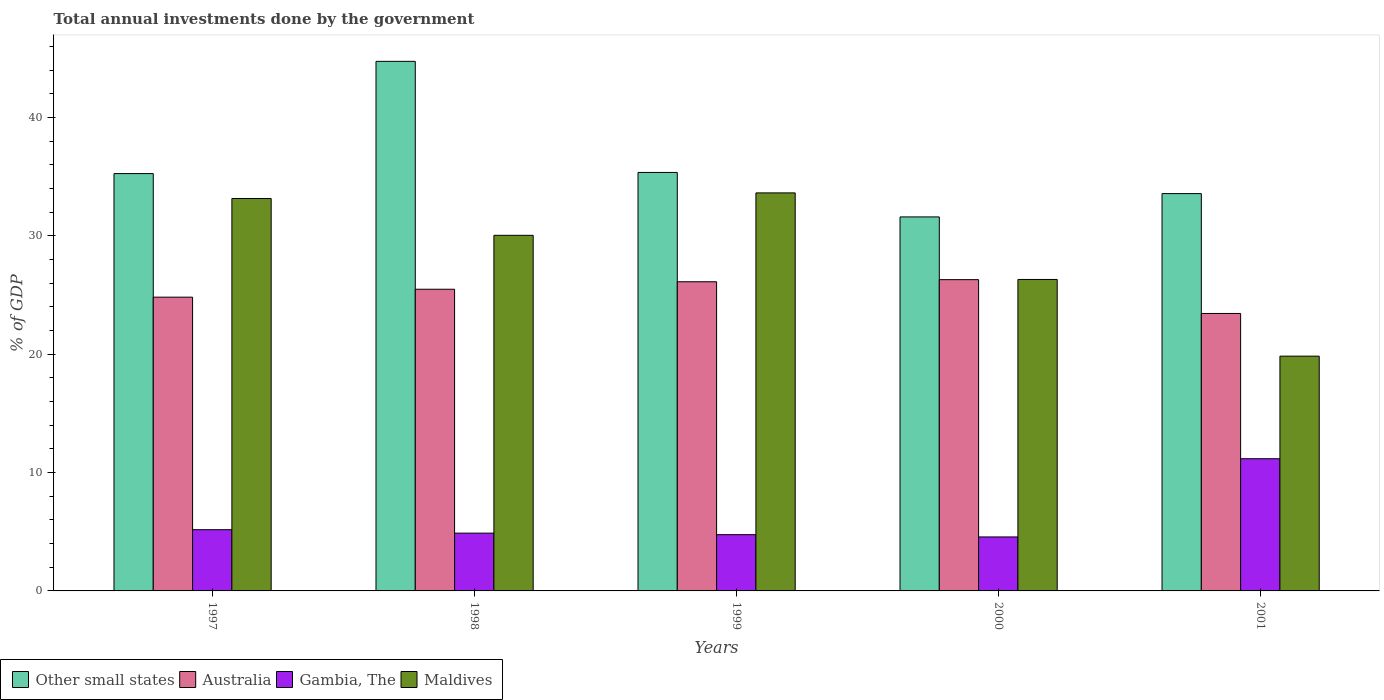How many different coloured bars are there?
Your answer should be compact. 4. Are the number of bars per tick equal to the number of legend labels?
Provide a succinct answer. Yes. What is the total annual investments done by the government in Other small states in 1997?
Make the answer very short. 35.27. Across all years, what is the maximum total annual investments done by the government in Maldives?
Give a very brief answer. 33.64. Across all years, what is the minimum total annual investments done by the government in Other small states?
Offer a very short reply. 31.61. What is the total total annual investments done by the government in Maldives in the graph?
Offer a terse response. 143.03. What is the difference between the total annual investments done by the government in Maldives in 1997 and that in 1999?
Offer a terse response. -0.47. What is the difference between the total annual investments done by the government in Maldives in 2000 and the total annual investments done by the government in Australia in 1997?
Offer a terse response. 1.5. What is the average total annual investments done by the government in Other small states per year?
Give a very brief answer. 36.12. In the year 1999, what is the difference between the total annual investments done by the government in Gambia, The and total annual investments done by the government in Other small states?
Offer a terse response. -30.61. In how many years, is the total annual investments done by the government in Maldives greater than 14 %?
Your answer should be compact. 5. What is the ratio of the total annual investments done by the government in Other small states in 1998 to that in 2001?
Provide a succinct answer. 1.33. Is the total annual investments done by the government in Australia in 1999 less than that in 2001?
Give a very brief answer. No. Is the difference between the total annual investments done by the government in Gambia, The in 1997 and 2001 greater than the difference between the total annual investments done by the government in Other small states in 1997 and 2001?
Your answer should be compact. No. What is the difference between the highest and the second highest total annual investments done by the government in Other small states?
Provide a succinct answer. 9.39. What is the difference between the highest and the lowest total annual investments done by the government in Other small states?
Keep it short and to the point. 13.15. In how many years, is the total annual investments done by the government in Gambia, The greater than the average total annual investments done by the government in Gambia, The taken over all years?
Offer a terse response. 1. What does the 1st bar from the left in 1998 represents?
Your answer should be compact. Other small states. Is it the case that in every year, the sum of the total annual investments done by the government in Gambia, The and total annual investments done by the government in Maldives is greater than the total annual investments done by the government in Australia?
Your answer should be compact. Yes. Are all the bars in the graph horizontal?
Make the answer very short. No. What is the difference between two consecutive major ticks on the Y-axis?
Provide a succinct answer. 10. Are the values on the major ticks of Y-axis written in scientific E-notation?
Your answer should be very brief. No. Does the graph contain any zero values?
Ensure brevity in your answer.  No. Does the graph contain grids?
Your response must be concise. No. How many legend labels are there?
Keep it short and to the point. 4. What is the title of the graph?
Keep it short and to the point. Total annual investments done by the government. Does "Senegal" appear as one of the legend labels in the graph?
Provide a succinct answer. No. What is the label or title of the Y-axis?
Offer a very short reply. % of GDP. What is the % of GDP of Other small states in 1997?
Provide a succinct answer. 35.27. What is the % of GDP in Australia in 1997?
Your answer should be compact. 24.83. What is the % of GDP of Gambia, The in 1997?
Keep it short and to the point. 5.18. What is the % of GDP in Maldives in 1997?
Provide a succinct answer. 33.17. What is the % of GDP of Other small states in 1998?
Give a very brief answer. 44.76. What is the % of GDP in Australia in 1998?
Provide a short and direct response. 25.5. What is the % of GDP in Gambia, The in 1998?
Make the answer very short. 4.88. What is the % of GDP of Maldives in 1998?
Give a very brief answer. 30.05. What is the % of GDP in Other small states in 1999?
Offer a very short reply. 35.37. What is the % of GDP of Australia in 1999?
Make the answer very short. 26.13. What is the % of GDP in Gambia, The in 1999?
Offer a terse response. 4.76. What is the % of GDP of Maldives in 1999?
Your answer should be compact. 33.64. What is the % of GDP in Other small states in 2000?
Your answer should be very brief. 31.61. What is the % of GDP in Australia in 2000?
Provide a short and direct response. 26.31. What is the % of GDP in Gambia, The in 2000?
Make the answer very short. 4.56. What is the % of GDP in Maldives in 2000?
Your answer should be compact. 26.32. What is the % of GDP of Other small states in 2001?
Your response must be concise. 33.58. What is the % of GDP in Australia in 2001?
Your response must be concise. 23.45. What is the % of GDP of Gambia, The in 2001?
Make the answer very short. 11.17. What is the % of GDP of Maldives in 2001?
Your answer should be compact. 19.84. Across all years, what is the maximum % of GDP of Other small states?
Your answer should be very brief. 44.76. Across all years, what is the maximum % of GDP of Australia?
Offer a terse response. 26.31. Across all years, what is the maximum % of GDP in Gambia, The?
Provide a succinct answer. 11.17. Across all years, what is the maximum % of GDP in Maldives?
Keep it short and to the point. 33.64. Across all years, what is the minimum % of GDP in Other small states?
Offer a terse response. 31.61. Across all years, what is the minimum % of GDP of Australia?
Offer a terse response. 23.45. Across all years, what is the minimum % of GDP in Gambia, The?
Provide a short and direct response. 4.56. Across all years, what is the minimum % of GDP in Maldives?
Give a very brief answer. 19.84. What is the total % of GDP of Other small states in the graph?
Keep it short and to the point. 180.59. What is the total % of GDP in Australia in the graph?
Provide a short and direct response. 126.21. What is the total % of GDP in Gambia, The in the graph?
Make the answer very short. 30.55. What is the total % of GDP in Maldives in the graph?
Provide a short and direct response. 143.03. What is the difference between the % of GDP of Other small states in 1997 and that in 1998?
Provide a short and direct response. -9.49. What is the difference between the % of GDP in Australia in 1997 and that in 1998?
Offer a very short reply. -0.67. What is the difference between the % of GDP of Gambia, The in 1997 and that in 1998?
Keep it short and to the point. 0.29. What is the difference between the % of GDP in Maldives in 1997 and that in 1998?
Ensure brevity in your answer.  3.11. What is the difference between the % of GDP of Other small states in 1997 and that in 1999?
Provide a succinct answer. -0.1. What is the difference between the % of GDP in Australia in 1997 and that in 1999?
Provide a succinct answer. -1.3. What is the difference between the % of GDP in Gambia, The in 1997 and that in 1999?
Ensure brevity in your answer.  0.42. What is the difference between the % of GDP in Maldives in 1997 and that in 1999?
Your answer should be very brief. -0.47. What is the difference between the % of GDP in Other small states in 1997 and that in 2000?
Keep it short and to the point. 3.66. What is the difference between the % of GDP in Australia in 1997 and that in 2000?
Make the answer very short. -1.48. What is the difference between the % of GDP in Gambia, The in 1997 and that in 2000?
Keep it short and to the point. 0.61. What is the difference between the % of GDP of Maldives in 1997 and that in 2000?
Your response must be concise. 6.84. What is the difference between the % of GDP in Other small states in 1997 and that in 2001?
Provide a succinct answer. 1.69. What is the difference between the % of GDP of Australia in 1997 and that in 2001?
Provide a short and direct response. 1.38. What is the difference between the % of GDP in Gambia, The in 1997 and that in 2001?
Keep it short and to the point. -6. What is the difference between the % of GDP in Maldives in 1997 and that in 2001?
Keep it short and to the point. 13.32. What is the difference between the % of GDP of Other small states in 1998 and that in 1999?
Your answer should be very brief. 9.39. What is the difference between the % of GDP of Australia in 1998 and that in 1999?
Provide a short and direct response. -0.63. What is the difference between the % of GDP in Gambia, The in 1998 and that in 1999?
Make the answer very short. 0.13. What is the difference between the % of GDP of Maldives in 1998 and that in 1999?
Your answer should be very brief. -3.59. What is the difference between the % of GDP of Other small states in 1998 and that in 2000?
Make the answer very short. 13.15. What is the difference between the % of GDP in Australia in 1998 and that in 2000?
Your answer should be very brief. -0.81. What is the difference between the % of GDP in Gambia, The in 1998 and that in 2000?
Make the answer very short. 0.32. What is the difference between the % of GDP of Maldives in 1998 and that in 2000?
Offer a terse response. 3.73. What is the difference between the % of GDP of Other small states in 1998 and that in 2001?
Make the answer very short. 11.18. What is the difference between the % of GDP in Australia in 1998 and that in 2001?
Your answer should be compact. 2.05. What is the difference between the % of GDP in Gambia, The in 1998 and that in 2001?
Provide a succinct answer. -6.29. What is the difference between the % of GDP of Maldives in 1998 and that in 2001?
Your answer should be compact. 10.21. What is the difference between the % of GDP in Other small states in 1999 and that in 2000?
Offer a terse response. 3.76. What is the difference between the % of GDP of Australia in 1999 and that in 2000?
Provide a short and direct response. -0.18. What is the difference between the % of GDP of Gambia, The in 1999 and that in 2000?
Offer a terse response. 0.19. What is the difference between the % of GDP in Maldives in 1999 and that in 2000?
Your answer should be compact. 7.32. What is the difference between the % of GDP of Other small states in 1999 and that in 2001?
Offer a terse response. 1.79. What is the difference between the % of GDP in Australia in 1999 and that in 2001?
Offer a terse response. 2.68. What is the difference between the % of GDP of Gambia, The in 1999 and that in 2001?
Provide a succinct answer. -6.42. What is the difference between the % of GDP of Maldives in 1999 and that in 2001?
Provide a succinct answer. 13.8. What is the difference between the % of GDP in Other small states in 2000 and that in 2001?
Offer a terse response. -1.97. What is the difference between the % of GDP of Australia in 2000 and that in 2001?
Keep it short and to the point. 2.86. What is the difference between the % of GDP of Gambia, The in 2000 and that in 2001?
Offer a very short reply. -6.61. What is the difference between the % of GDP in Maldives in 2000 and that in 2001?
Keep it short and to the point. 6.48. What is the difference between the % of GDP of Other small states in 1997 and the % of GDP of Australia in 1998?
Provide a succinct answer. 9.78. What is the difference between the % of GDP in Other small states in 1997 and the % of GDP in Gambia, The in 1998?
Your response must be concise. 30.39. What is the difference between the % of GDP in Other small states in 1997 and the % of GDP in Maldives in 1998?
Provide a succinct answer. 5.22. What is the difference between the % of GDP of Australia in 1997 and the % of GDP of Gambia, The in 1998?
Give a very brief answer. 19.94. What is the difference between the % of GDP of Australia in 1997 and the % of GDP of Maldives in 1998?
Give a very brief answer. -5.23. What is the difference between the % of GDP of Gambia, The in 1997 and the % of GDP of Maldives in 1998?
Your answer should be compact. -24.88. What is the difference between the % of GDP in Other small states in 1997 and the % of GDP in Australia in 1999?
Your answer should be compact. 9.14. What is the difference between the % of GDP of Other small states in 1997 and the % of GDP of Gambia, The in 1999?
Give a very brief answer. 30.52. What is the difference between the % of GDP in Other small states in 1997 and the % of GDP in Maldives in 1999?
Your response must be concise. 1.63. What is the difference between the % of GDP in Australia in 1997 and the % of GDP in Gambia, The in 1999?
Provide a short and direct response. 20.07. What is the difference between the % of GDP in Australia in 1997 and the % of GDP in Maldives in 1999?
Your answer should be very brief. -8.81. What is the difference between the % of GDP of Gambia, The in 1997 and the % of GDP of Maldives in 1999?
Your answer should be very brief. -28.46. What is the difference between the % of GDP of Other small states in 1997 and the % of GDP of Australia in 2000?
Keep it short and to the point. 8.96. What is the difference between the % of GDP of Other small states in 1997 and the % of GDP of Gambia, The in 2000?
Offer a very short reply. 30.71. What is the difference between the % of GDP in Other small states in 1997 and the % of GDP in Maldives in 2000?
Give a very brief answer. 8.95. What is the difference between the % of GDP of Australia in 1997 and the % of GDP of Gambia, The in 2000?
Your answer should be very brief. 20.27. What is the difference between the % of GDP in Australia in 1997 and the % of GDP in Maldives in 2000?
Offer a terse response. -1.5. What is the difference between the % of GDP of Gambia, The in 1997 and the % of GDP of Maldives in 2000?
Your answer should be very brief. -21.15. What is the difference between the % of GDP of Other small states in 1997 and the % of GDP of Australia in 2001?
Your response must be concise. 11.82. What is the difference between the % of GDP of Other small states in 1997 and the % of GDP of Gambia, The in 2001?
Offer a terse response. 24.1. What is the difference between the % of GDP of Other small states in 1997 and the % of GDP of Maldives in 2001?
Make the answer very short. 15.43. What is the difference between the % of GDP in Australia in 1997 and the % of GDP in Gambia, The in 2001?
Offer a very short reply. 13.65. What is the difference between the % of GDP of Australia in 1997 and the % of GDP of Maldives in 2001?
Provide a short and direct response. 4.98. What is the difference between the % of GDP of Gambia, The in 1997 and the % of GDP of Maldives in 2001?
Offer a terse response. -14.67. What is the difference between the % of GDP of Other small states in 1998 and the % of GDP of Australia in 1999?
Ensure brevity in your answer.  18.63. What is the difference between the % of GDP in Other small states in 1998 and the % of GDP in Gambia, The in 1999?
Your response must be concise. 40. What is the difference between the % of GDP of Other small states in 1998 and the % of GDP of Maldives in 1999?
Ensure brevity in your answer.  11.12. What is the difference between the % of GDP in Australia in 1998 and the % of GDP in Gambia, The in 1999?
Provide a succinct answer. 20.74. What is the difference between the % of GDP in Australia in 1998 and the % of GDP in Maldives in 1999?
Your response must be concise. -8.14. What is the difference between the % of GDP of Gambia, The in 1998 and the % of GDP of Maldives in 1999?
Provide a succinct answer. -28.76. What is the difference between the % of GDP of Other small states in 1998 and the % of GDP of Australia in 2000?
Keep it short and to the point. 18.45. What is the difference between the % of GDP of Other small states in 1998 and the % of GDP of Gambia, The in 2000?
Keep it short and to the point. 40.19. What is the difference between the % of GDP in Other small states in 1998 and the % of GDP in Maldives in 2000?
Provide a short and direct response. 18.43. What is the difference between the % of GDP in Australia in 1998 and the % of GDP in Gambia, The in 2000?
Provide a succinct answer. 20.93. What is the difference between the % of GDP in Australia in 1998 and the % of GDP in Maldives in 2000?
Make the answer very short. -0.83. What is the difference between the % of GDP of Gambia, The in 1998 and the % of GDP of Maldives in 2000?
Offer a very short reply. -21.44. What is the difference between the % of GDP in Other small states in 1998 and the % of GDP in Australia in 2001?
Provide a succinct answer. 21.31. What is the difference between the % of GDP of Other small states in 1998 and the % of GDP of Gambia, The in 2001?
Ensure brevity in your answer.  33.58. What is the difference between the % of GDP in Other small states in 1998 and the % of GDP in Maldives in 2001?
Offer a terse response. 24.91. What is the difference between the % of GDP in Australia in 1998 and the % of GDP in Gambia, The in 2001?
Keep it short and to the point. 14.32. What is the difference between the % of GDP of Australia in 1998 and the % of GDP of Maldives in 2001?
Give a very brief answer. 5.65. What is the difference between the % of GDP of Gambia, The in 1998 and the % of GDP of Maldives in 2001?
Your answer should be very brief. -14.96. What is the difference between the % of GDP of Other small states in 1999 and the % of GDP of Australia in 2000?
Your response must be concise. 9.06. What is the difference between the % of GDP in Other small states in 1999 and the % of GDP in Gambia, The in 2000?
Ensure brevity in your answer.  30.81. What is the difference between the % of GDP of Other small states in 1999 and the % of GDP of Maldives in 2000?
Offer a terse response. 9.05. What is the difference between the % of GDP in Australia in 1999 and the % of GDP in Gambia, The in 2000?
Your response must be concise. 21.57. What is the difference between the % of GDP in Australia in 1999 and the % of GDP in Maldives in 2000?
Ensure brevity in your answer.  -0.19. What is the difference between the % of GDP of Gambia, The in 1999 and the % of GDP of Maldives in 2000?
Offer a very short reply. -21.57. What is the difference between the % of GDP in Other small states in 1999 and the % of GDP in Australia in 2001?
Keep it short and to the point. 11.92. What is the difference between the % of GDP of Other small states in 1999 and the % of GDP of Gambia, The in 2001?
Give a very brief answer. 24.2. What is the difference between the % of GDP of Other small states in 1999 and the % of GDP of Maldives in 2001?
Provide a succinct answer. 15.53. What is the difference between the % of GDP of Australia in 1999 and the % of GDP of Gambia, The in 2001?
Your answer should be compact. 14.96. What is the difference between the % of GDP in Australia in 1999 and the % of GDP in Maldives in 2001?
Your answer should be very brief. 6.29. What is the difference between the % of GDP in Gambia, The in 1999 and the % of GDP in Maldives in 2001?
Keep it short and to the point. -15.09. What is the difference between the % of GDP of Other small states in 2000 and the % of GDP of Australia in 2001?
Your response must be concise. 8.16. What is the difference between the % of GDP of Other small states in 2000 and the % of GDP of Gambia, The in 2001?
Your answer should be compact. 20.44. What is the difference between the % of GDP in Other small states in 2000 and the % of GDP in Maldives in 2001?
Your response must be concise. 11.77. What is the difference between the % of GDP in Australia in 2000 and the % of GDP in Gambia, The in 2001?
Your answer should be very brief. 15.13. What is the difference between the % of GDP in Australia in 2000 and the % of GDP in Maldives in 2001?
Provide a succinct answer. 6.46. What is the difference between the % of GDP in Gambia, The in 2000 and the % of GDP in Maldives in 2001?
Give a very brief answer. -15.28. What is the average % of GDP in Other small states per year?
Your answer should be compact. 36.12. What is the average % of GDP in Australia per year?
Offer a very short reply. 25.24. What is the average % of GDP in Gambia, The per year?
Offer a very short reply. 6.11. What is the average % of GDP of Maldives per year?
Offer a very short reply. 28.61. In the year 1997, what is the difference between the % of GDP of Other small states and % of GDP of Australia?
Your answer should be very brief. 10.44. In the year 1997, what is the difference between the % of GDP in Other small states and % of GDP in Gambia, The?
Make the answer very short. 30.1. In the year 1997, what is the difference between the % of GDP of Other small states and % of GDP of Maldives?
Provide a succinct answer. 2.11. In the year 1997, what is the difference between the % of GDP of Australia and % of GDP of Gambia, The?
Give a very brief answer. 19.65. In the year 1997, what is the difference between the % of GDP of Australia and % of GDP of Maldives?
Offer a very short reply. -8.34. In the year 1997, what is the difference between the % of GDP in Gambia, The and % of GDP in Maldives?
Keep it short and to the point. -27.99. In the year 1998, what is the difference between the % of GDP in Other small states and % of GDP in Australia?
Your response must be concise. 19.26. In the year 1998, what is the difference between the % of GDP in Other small states and % of GDP in Gambia, The?
Give a very brief answer. 39.87. In the year 1998, what is the difference between the % of GDP of Other small states and % of GDP of Maldives?
Keep it short and to the point. 14.7. In the year 1998, what is the difference between the % of GDP in Australia and % of GDP in Gambia, The?
Your response must be concise. 20.61. In the year 1998, what is the difference between the % of GDP of Australia and % of GDP of Maldives?
Give a very brief answer. -4.56. In the year 1998, what is the difference between the % of GDP in Gambia, The and % of GDP in Maldives?
Give a very brief answer. -25.17. In the year 1999, what is the difference between the % of GDP in Other small states and % of GDP in Australia?
Make the answer very short. 9.24. In the year 1999, what is the difference between the % of GDP in Other small states and % of GDP in Gambia, The?
Ensure brevity in your answer.  30.61. In the year 1999, what is the difference between the % of GDP in Other small states and % of GDP in Maldives?
Provide a short and direct response. 1.73. In the year 1999, what is the difference between the % of GDP in Australia and % of GDP in Gambia, The?
Your answer should be compact. 21.37. In the year 1999, what is the difference between the % of GDP of Australia and % of GDP of Maldives?
Your answer should be compact. -7.51. In the year 1999, what is the difference between the % of GDP of Gambia, The and % of GDP of Maldives?
Your response must be concise. -28.88. In the year 2000, what is the difference between the % of GDP of Other small states and % of GDP of Australia?
Your answer should be very brief. 5.3. In the year 2000, what is the difference between the % of GDP of Other small states and % of GDP of Gambia, The?
Make the answer very short. 27.05. In the year 2000, what is the difference between the % of GDP in Other small states and % of GDP in Maldives?
Keep it short and to the point. 5.29. In the year 2000, what is the difference between the % of GDP in Australia and % of GDP in Gambia, The?
Offer a terse response. 21.75. In the year 2000, what is the difference between the % of GDP of Australia and % of GDP of Maldives?
Keep it short and to the point. -0.02. In the year 2000, what is the difference between the % of GDP of Gambia, The and % of GDP of Maldives?
Make the answer very short. -21.76. In the year 2001, what is the difference between the % of GDP of Other small states and % of GDP of Australia?
Make the answer very short. 10.13. In the year 2001, what is the difference between the % of GDP of Other small states and % of GDP of Gambia, The?
Offer a very short reply. 22.41. In the year 2001, what is the difference between the % of GDP in Other small states and % of GDP in Maldives?
Your answer should be very brief. 13.74. In the year 2001, what is the difference between the % of GDP in Australia and % of GDP in Gambia, The?
Provide a succinct answer. 12.28. In the year 2001, what is the difference between the % of GDP of Australia and % of GDP of Maldives?
Provide a short and direct response. 3.61. In the year 2001, what is the difference between the % of GDP of Gambia, The and % of GDP of Maldives?
Provide a succinct answer. -8.67. What is the ratio of the % of GDP of Other small states in 1997 to that in 1998?
Keep it short and to the point. 0.79. What is the ratio of the % of GDP of Australia in 1997 to that in 1998?
Your response must be concise. 0.97. What is the ratio of the % of GDP of Gambia, The in 1997 to that in 1998?
Provide a succinct answer. 1.06. What is the ratio of the % of GDP in Maldives in 1997 to that in 1998?
Ensure brevity in your answer.  1.1. What is the ratio of the % of GDP in Australia in 1997 to that in 1999?
Provide a short and direct response. 0.95. What is the ratio of the % of GDP of Gambia, The in 1997 to that in 1999?
Your answer should be very brief. 1.09. What is the ratio of the % of GDP of Maldives in 1997 to that in 1999?
Keep it short and to the point. 0.99. What is the ratio of the % of GDP in Other small states in 1997 to that in 2000?
Offer a very short reply. 1.12. What is the ratio of the % of GDP of Australia in 1997 to that in 2000?
Make the answer very short. 0.94. What is the ratio of the % of GDP in Gambia, The in 1997 to that in 2000?
Provide a short and direct response. 1.13. What is the ratio of the % of GDP in Maldives in 1997 to that in 2000?
Your answer should be compact. 1.26. What is the ratio of the % of GDP in Other small states in 1997 to that in 2001?
Offer a very short reply. 1.05. What is the ratio of the % of GDP in Australia in 1997 to that in 2001?
Give a very brief answer. 1.06. What is the ratio of the % of GDP of Gambia, The in 1997 to that in 2001?
Keep it short and to the point. 0.46. What is the ratio of the % of GDP of Maldives in 1997 to that in 2001?
Your answer should be compact. 1.67. What is the ratio of the % of GDP in Other small states in 1998 to that in 1999?
Your answer should be very brief. 1.27. What is the ratio of the % of GDP of Australia in 1998 to that in 1999?
Ensure brevity in your answer.  0.98. What is the ratio of the % of GDP in Gambia, The in 1998 to that in 1999?
Provide a short and direct response. 1.03. What is the ratio of the % of GDP of Maldives in 1998 to that in 1999?
Make the answer very short. 0.89. What is the ratio of the % of GDP of Other small states in 1998 to that in 2000?
Offer a very short reply. 1.42. What is the ratio of the % of GDP of Australia in 1998 to that in 2000?
Give a very brief answer. 0.97. What is the ratio of the % of GDP in Gambia, The in 1998 to that in 2000?
Make the answer very short. 1.07. What is the ratio of the % of GDP in Maldives in 1998 to that in 2000?
Ensure brevity in your answer.  1.14. What is the ratio of the % of GDP in Other small states in 1998 to that in 2001?
Your answer should be compact. 1.33. What is the ratio of the % of GDP of Australia in 1998 to that in 2001?
Offer a terse response. 1.09. What is the ratio of the % of GDP in Gambia, The in 1998 to that in 2001?
Your answer should be very brief. 0.44. What is the ratio of the % of GDP in Maldives in 1998 to that in 2001?
Give a very brief answer. 1.51. What is the ratio of the % of GDP in Other small states in 1999 to that in 2000?
Offer a very short reply. 1.12. What is the ratio of the % of GDP in Australia in 1999 to that in 2000?
Make the answer very short. 0.99. What is the ratio of the % of GDP in Gambia, The in 1999 to that in 2000?
Your response must be concise. 1.04. What is the ratio of the % of GDP in Maldives in 1999 to that in 2000?
Your response must be concise. 1.28. What is the ratio of the % of GDP in Other small states in 1999 to that in 2001?
Keep it short and to the point. 1.05. What is the ratio of the % of GDP of Australia in 1999 to that in 2001?
Ensure brevity in your answer.  1.11. What is the ratio of the % of GDP in Gambia, The in 1999 to that in 2001?
Provide a succinct answer. 0.43. What is the ratio of the % of GDP of Maldives in 1999 to that in 2001?
Provide a succinct answer. 1.7. What is the ratio of the % of GDP in Other small states in 2000 to that in 2001?
Your answer should be compact. 0.94. What is the ratio of the % of GDP of Australia in 2000 to that in 2001?
Provide a short and direct response. 1.12. What is the ratio of the % of GDP in Gambia, The in 2000 to that in 2001?
Provide a short and direct response. 0.41. What is the ratio of the % of GDP of Maldives in 2000 to that in 2001?
Keep it short and to the point. 1.33. What is the difference between the highest and the second highest % of GDP in Other small states?
Make the answer very short. 9.39. What is the difference between the highest and the second highest % of GDP in Australia?
Offer a very short reply. 0.18. What is the difference between the highest and the second highest % of GDP of Gambia, The?
Your response must be concise. 6. What is the difference between the highest and the second highest % of GDP in Maldives?
Make the answer very short. 0.47. What is the difference between the highest and the lowest % of GDP of Other small states?
Make the answer very short. 13.15. What is the difference between the highest and the lowest % of GDP in Australia?
Your answer should be very brief. 2.86. What is the difference between the highest and the lowest % of GDP of Gambia, The?
Ensure brevity in your answer.  6.61. What is the difference between the highest and the lowest % of GDP of Maldives?
Ensure brevity in your answer.  13.8. 